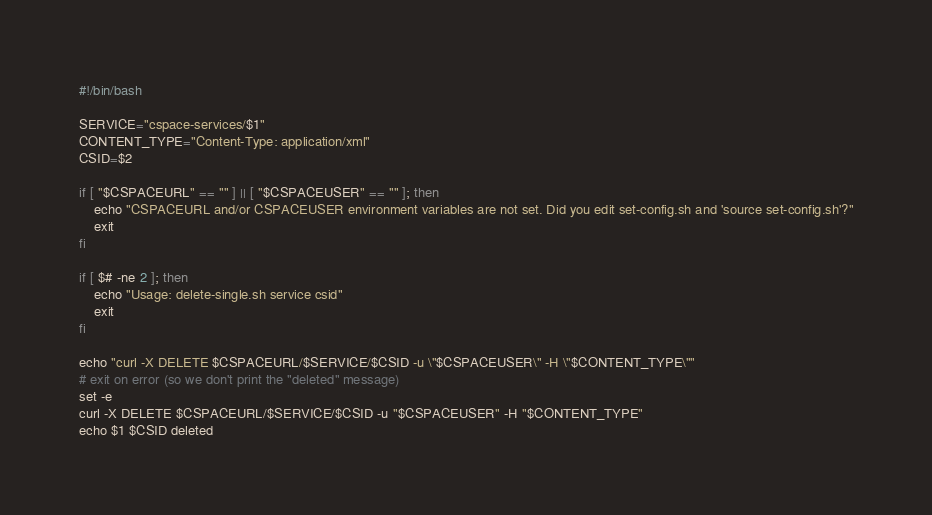<code> <loc_0><loc_0><loc_500><loc_500><_Bash_>#!/bin/bash

SERVICE="cspace-services/$1"
CONTENT_TYPE="Content-Type: application/xml"
CSID=$2

if [ "$CSPACEURL" == "" ] || [ "$CSPACEUSER" == "" ]; then
    echo "CSPACEURL and/or CSPACEUSER environment variables are not set. Did you edit set-config.sh and 'source set-config.sh'?"
    exit
fi

if [ $# -ne 2 ]; then
    echo "Usage: delete-single.sh service csid"
    exit
fi

echo "curl -X DELETE $CSPACEURL/$SERVICE/$CSID -u \"$CSPACEUSER\" -H \"$CONTENT_TYPE\""
# exit on error (so we don't print the "deleted" message)
set -e
curl -X DELETE $CSPACEURL/$SERVICE/$CSID -u "$CSPACEUSER" -H "$CONTENT_TYPE"
echo $1 $CSID deleted
</code> 